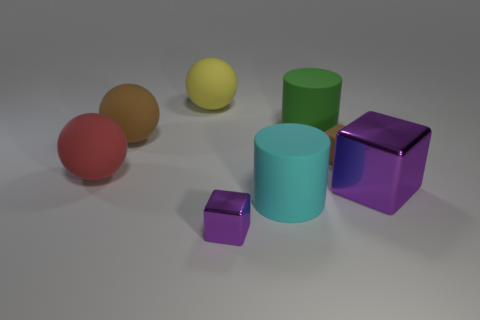Add 1 brown matte things. How many objects exist? 9 Subtract all cubes. How many objects are left? 5 Add 2 small metallic things. How many small metallic things exist? 3 Subtract 0 cyan blocks. How many objects are left? 8 Subtract all purple shiny blocks. Subtract all purple blocks. How many objects are left? 4 Add 5 cyan matte objects. How many cyan matte objects are left? 6 